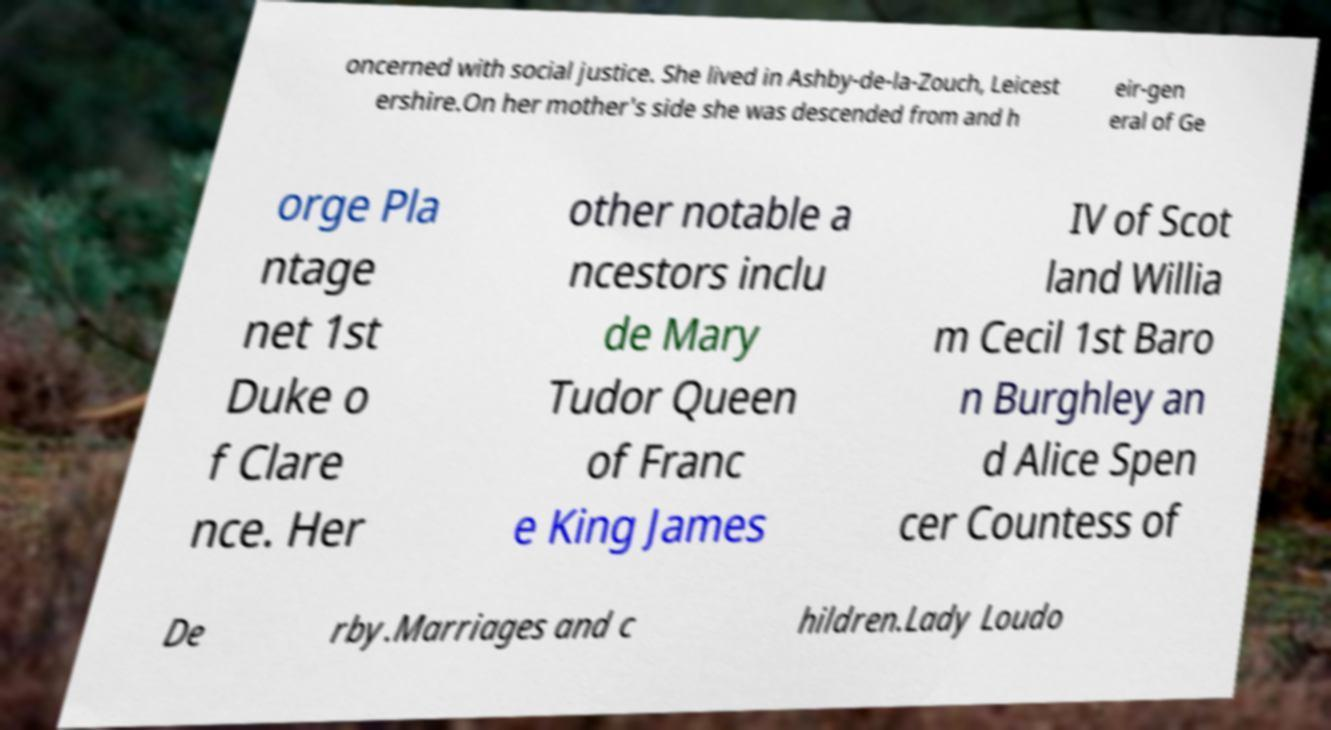I need the written content from this picture converted into text. Can you do that? oncerned with social justice. She lived in Ashby-de-la-Zouch, Leicest ershire.On her mother's side she was descended from and h eir-gen eral of Ge orge Pla ntage net 1st Duke o f Clare nce. Her other notable a ncestors inclu de Mary Tudor Queen of Franc e King James IV of Scot land Willia m Cecil 1st Baro n Burghley an d Alice Spen cer Countess of De rby.Marriages and c hildren.Lady Loudo 